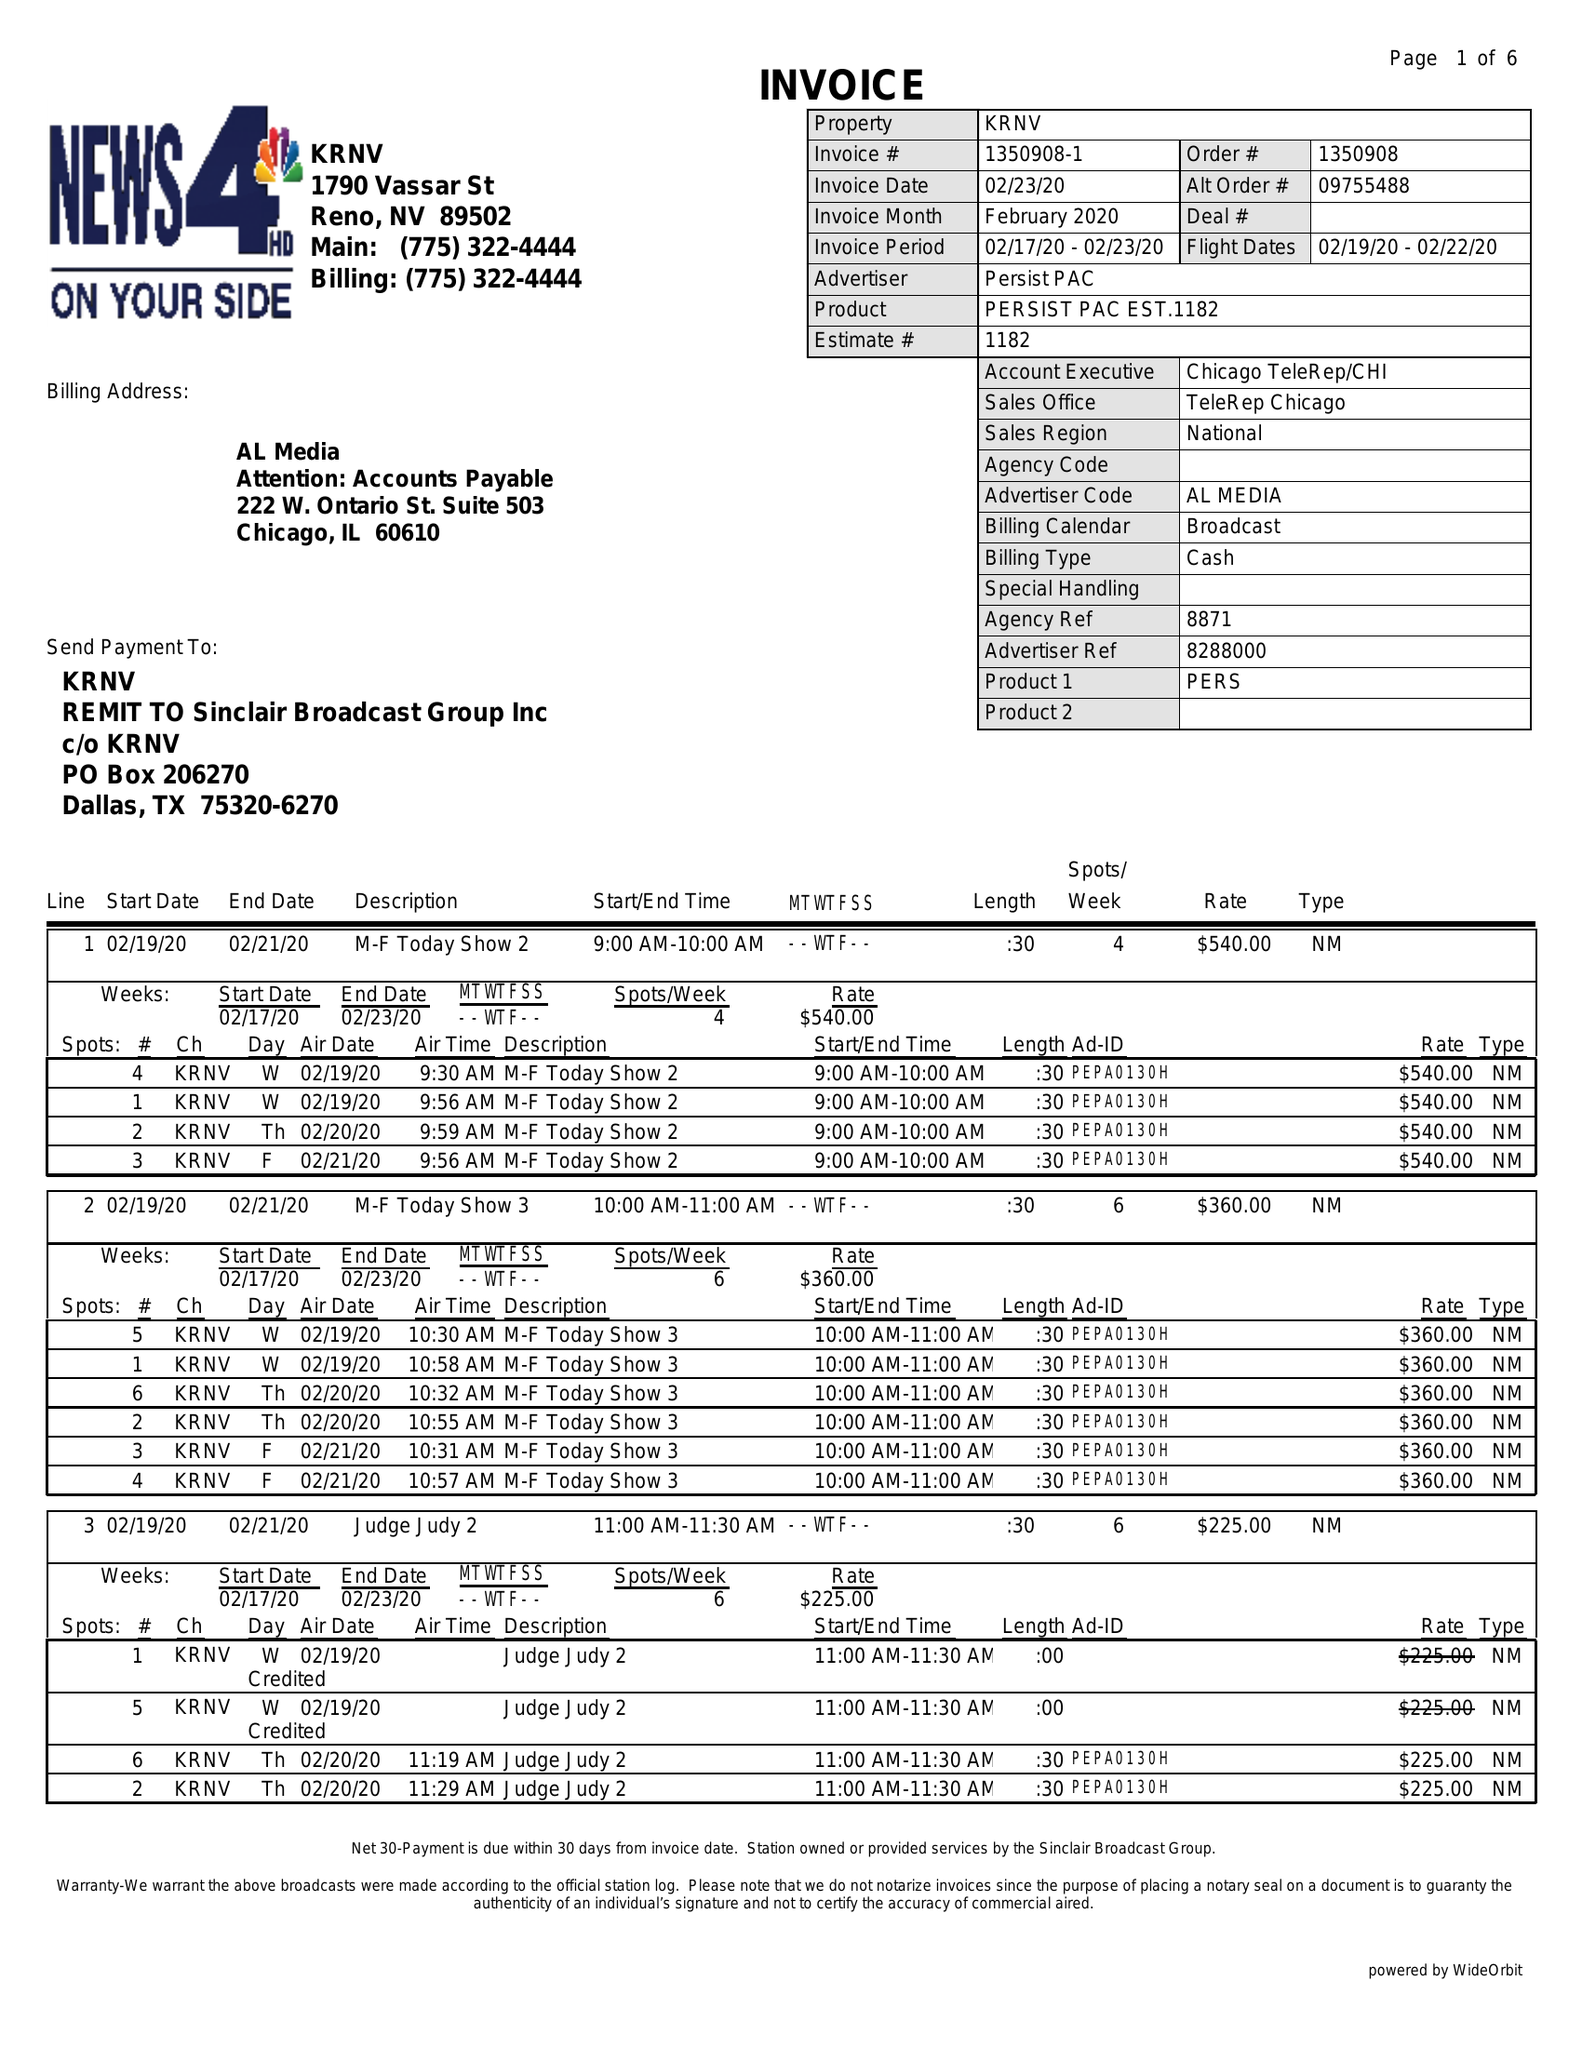What is the value for the flight_to?
Answer the question using a single word or phrase. 02/22/20 